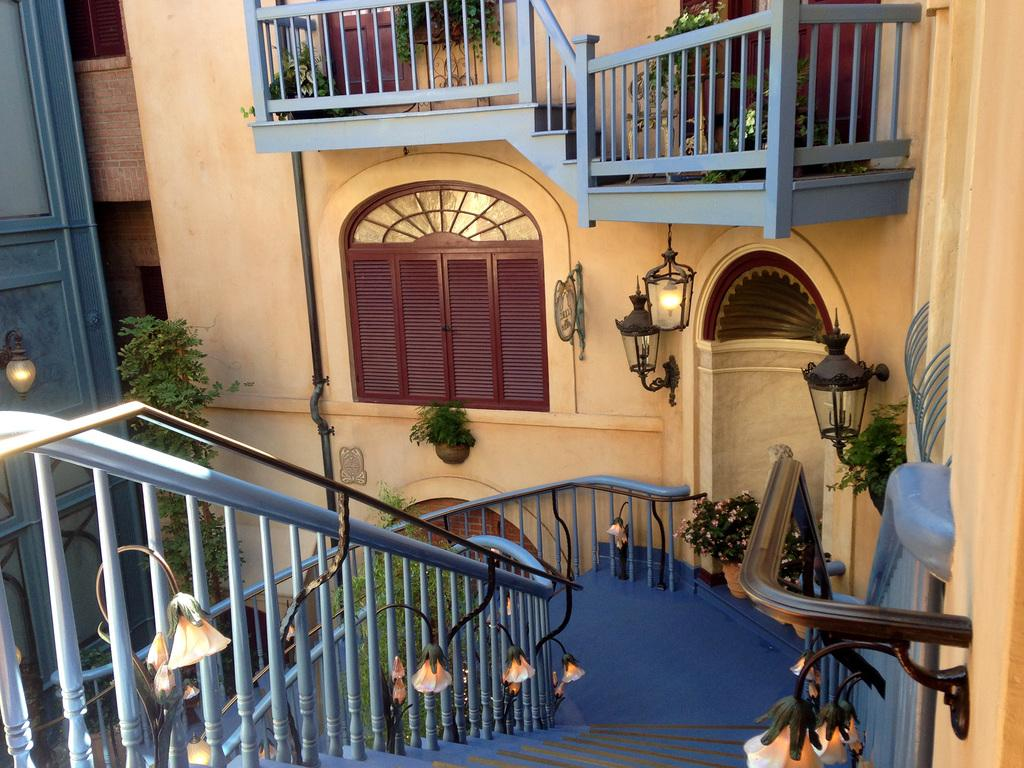What type of architectural feature can be seen in the image? There are railings and stairs in the image. What type of decorative elements are present in the image? There are potted plants in the image. What type of lighting is present in the image? There are lights in the image. What type of structure is visible in the image? There is a wall in the image. What type of openings are present in the wall? There are windows in the image. How many mines are visible in the image? There are no mines present in the image. What type of minute object can be seen in the image? There is no specific minute object mentioned in the facts provided, and the image does not show any small objects that stand out. 